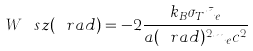Convert formula to latex. <formula><loc_0><loc_0><loc_500><loc_500>W ^ { \ } s z ( \ r a d ) = - 2 \frac { k _ { B } \sigma _ { T } \bar { n } _ { e } } { a ( \ r a d ) ^ { 2 } m _ { e } c ^ { 2 } }</formula> 